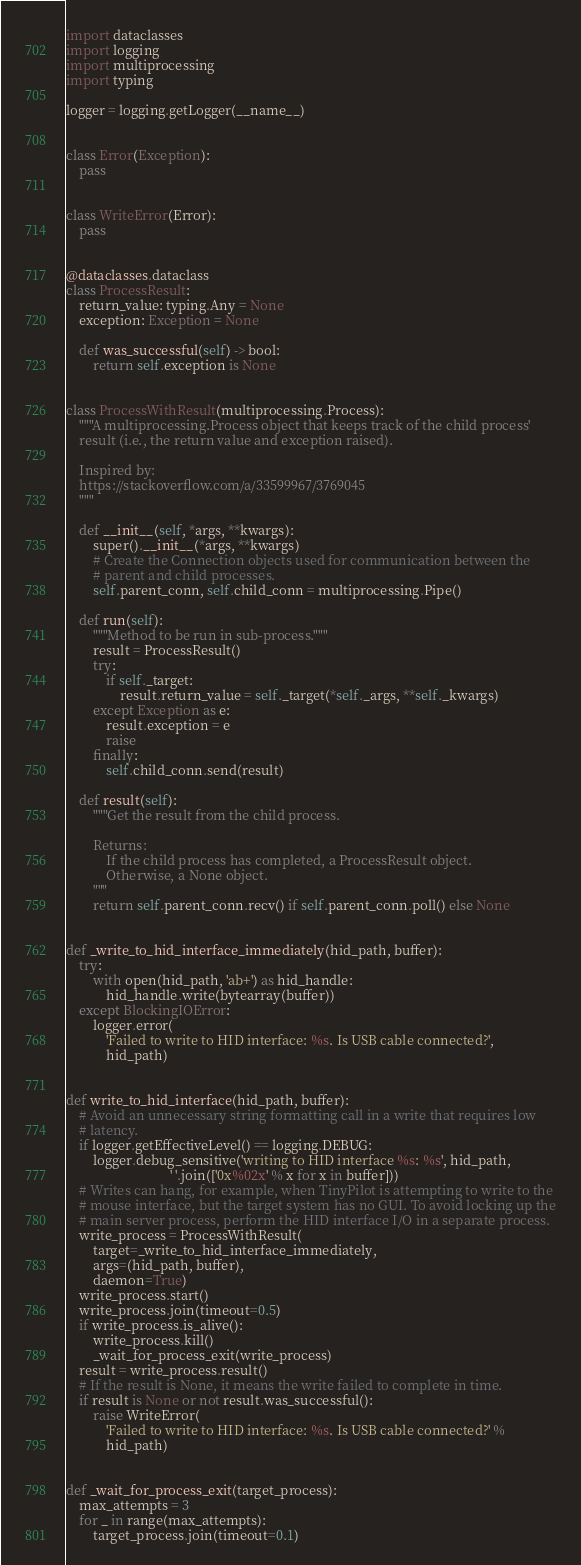<code> <loc_0><loc_0><loc_500><loc_500><_Python_>import dataclasses
import logging
import multiprocessing
import typing

logger = logging.getLogger(__name__)


class Error(Exception):
    pass


class WriteError(Error):
    pass


@dataclasses.dataclass
class ProcessResult:
    return_value: typing.Any = None
    exception: Exception = None

    def was_successful(self) -> bool:
        return self.exception is None


class ProcessWithResult(multiprocessing.Process):
    """A multiprocessing.Process object that keeps track of the child process'
    result (i.e., the return value and exception raised).

    Inspired by:
    https://stackoverflow.com/a/33599967/3769045
    """

    def __init__(self, *args, **kwargs):
        super().__init__(*args, **kwargs)
        # Create the Connection objects used for communication between the
        # parent and child processes.
        self.parent_conn, self.child_conn = multiprocessing.Pipe()

    def run(self):
        """Method to be run in sub-process."""
        result = ProcessResult()
        try:
            if self._target:
                result.return_value = self._target(*self._args, **self._kwargs)
        except Exception as e:
            result.exception = e
            raise
        finally:
            self.child_conn.send(result)

    def result(self):
        """Get the result from the child process.

        Returns:
            If the child process has completed, a ProcessResult object.
            Otherwise, a None object.
        """
        return self.parent_conn.recv() if self.parent_conn.poll() else None


def _write_to_hid_interface_immediately(hid_path, buffer):
    try:
        with open(hid_path, 'ab+') as hid_handle:
            hid_handle.write(bytearray(buffer))
    except BlockingIOError:
        logger.error(
            'Failed to write to HID interface: %s. Is USB cable connected?',
            hid_path)


def write_to_hid_interface(hid_path, buffer):
    # Avoid an unnecessary string formatting call in a write that requires low
    # latency.
    if logger.getEffectiveLevel() == logging.DEBUG:
        logger.debug_sensitive('writing to HID interface %s: %s', hid_path,
                               ' '.join(['0x%02x' % x for x in buffer]))
    # Writes can hang, for example, when TinyPilot is attempting to write to the
    # mouse interface, but the target system has no GUI. To avoid locking up the
    # main server process, perform the HID interface I/O in a separate process.
    write_process = ProcessWithResult(
        target=_write_to_hid_interface_immediately,
        args=(hid_path, buffer),
        daemon=True)
    write_process.start()
    write_process.join(timeout=0.5)
    if write_process.is_alive():
        write_process.kill()
        _wait_for_process_exit(write_process)
    result = write_process.result()
    # If the result is None, it means the write failed to complete in time.
    if result is None or not result.was_successful():
        raise WriteError(
            'Failed to write to HID interface: %s. Is USB cable connected?' %
            hid_path)


def _wait_for_process_exit(target_process):
    max_attempts = 3
    for _ in range(max_attempts):
        target_process.join(timeout=0.1)
</code> 